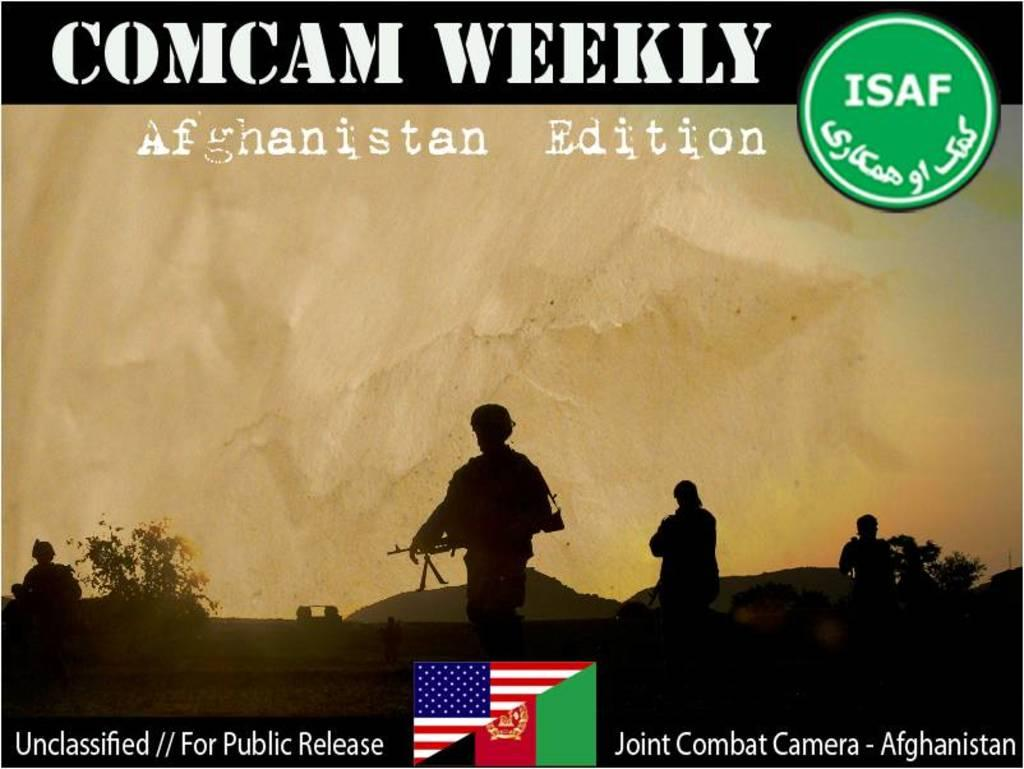<image>
Give a short and clear explanation of the subsequent image. A COMCAM Weekly by ISAF has an Afghanistan Edition 